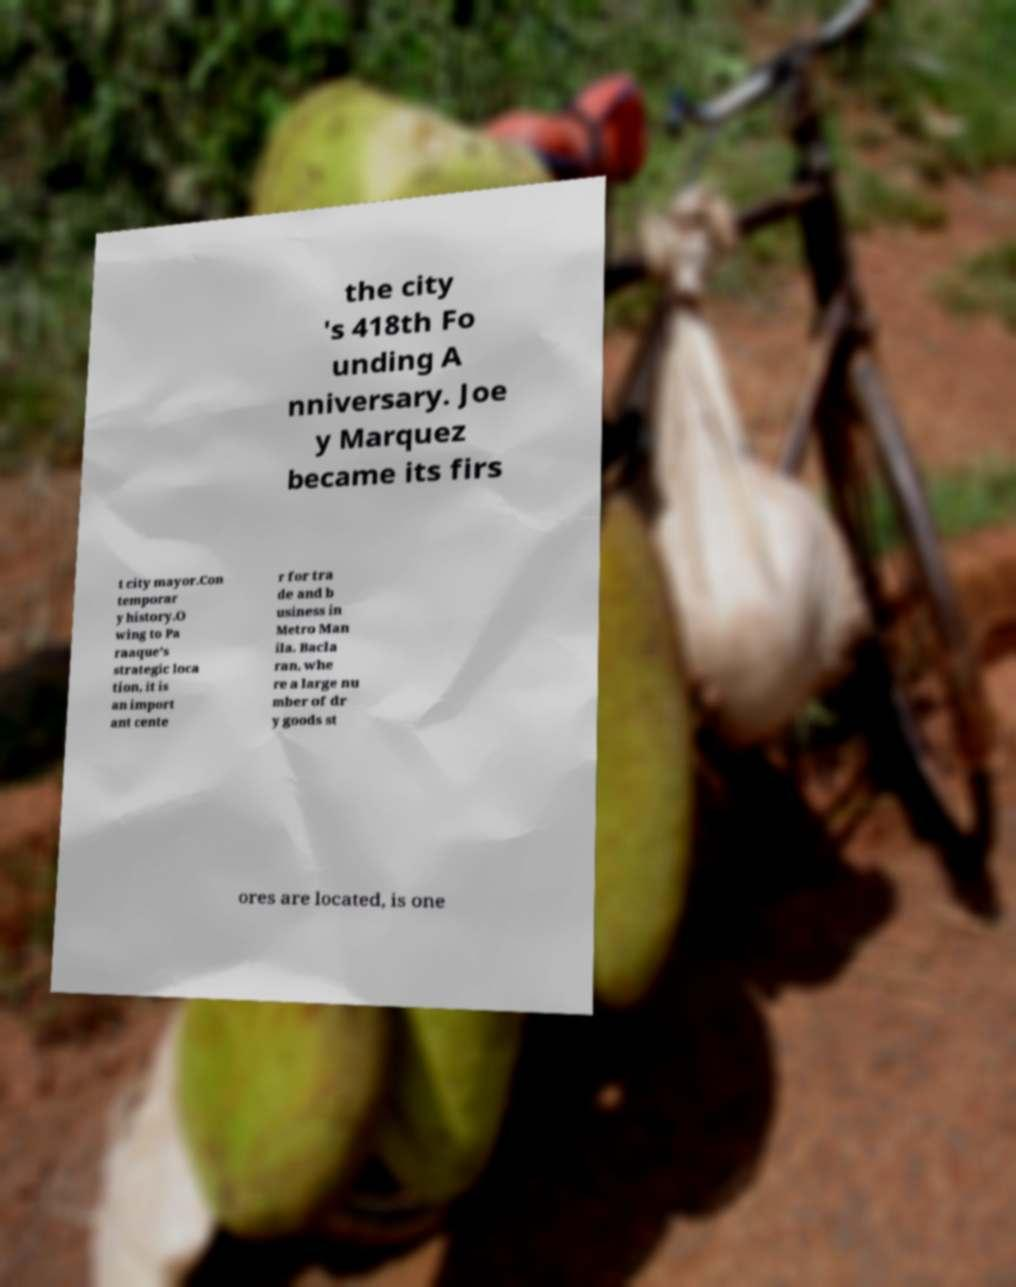Can you accurately transcribe the text from the provided image for me? the city 's 418th Fo unding A nniversary. Joe y Marquez became its firs t city mayor.Con temporar y history.O wing to Pa raaque's strategic loca tion, it is an import ant cente r for tra de and b usiness in Metro Man ila. Bacla ran, whe re a large nu mber of dr y goods st ores are located, is one 